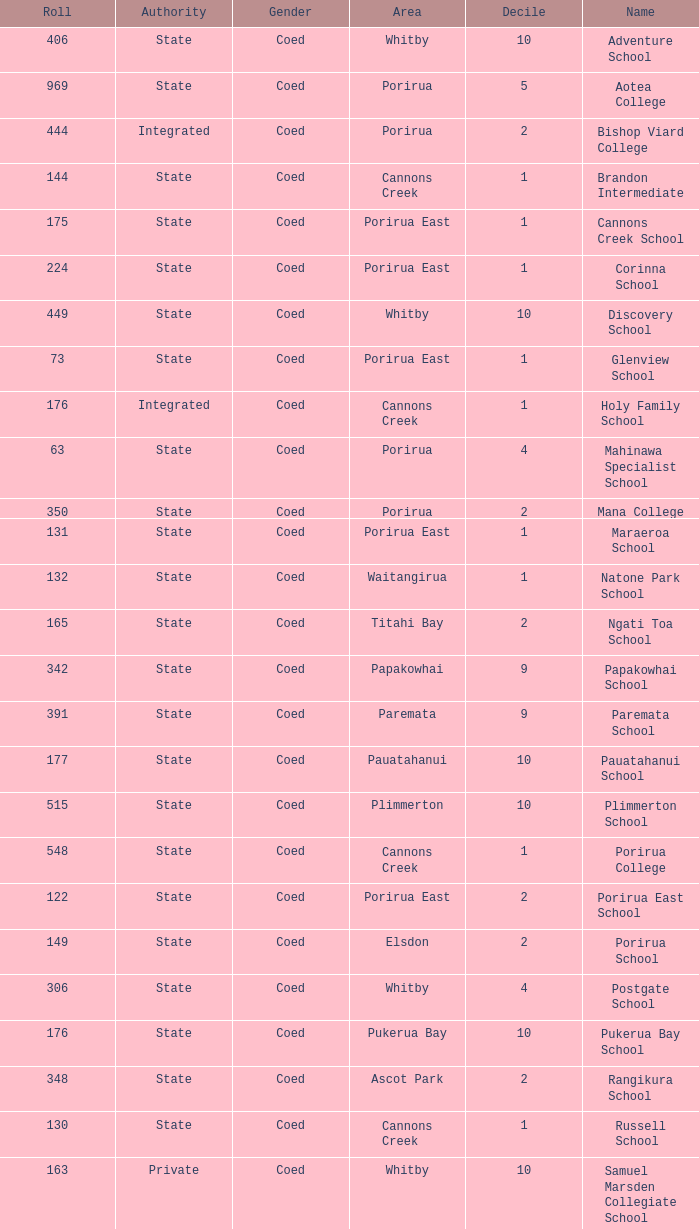What was the decile of Samuel Marsden Collegiate School in Whitby, when it had a roll higher than 163? 0.0. 